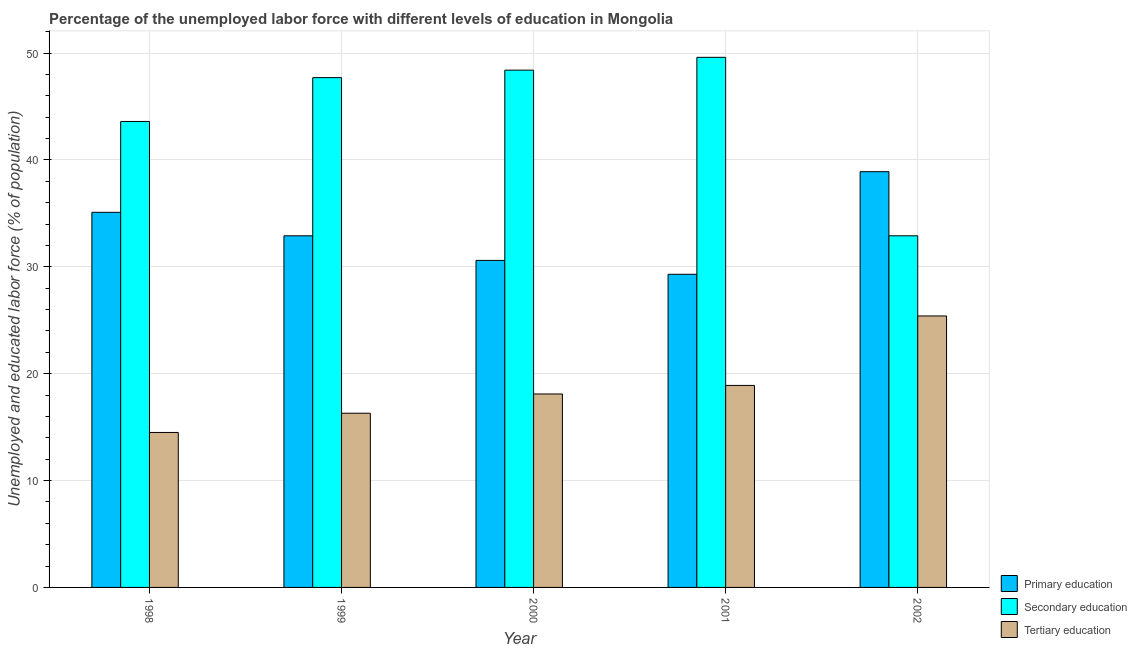Are the number of bars on each tick of the X-axis equal?
Ensure brevity in your answer.  Yes. How many bars are there on the 1st tick from the right?
Provide a short and direct response. 3. In how many cases, is the number of bars for a given year not equal to the number of legend labels?
Make the answer very short. 0. What is the percentage of labor force who received primary education in 1999?
Provide a short and direct response. 32.9. Across all years, what is the maximum percentage of labor force who received tertiary education?
Your response must be concise. 25.4. Across all years, what is the minimum percentage of labor force who received secondary education?
Offer a very short reply. 32.9. What is the total percentage of labor force who received secondary education in the graph?
Ensure brevity in your answer.  222.2. What is the difference between the percentage of labor force who received primary education in 1999 and that in 2002?
Keep it short and to the point. -6. What is the difference between the percentage of labor force who received secondary education in 1999 and the percentage of labor force who received primary education in 2001?
Give a very brief answer. -1.9. What is the average percentage of labor force who received tertiary education per year?
Make the answer very short. 18.64. In the year 1998, what is the difference between the percentage of labor force who received secondary education and percentage of labor force who received tertiary education?
Keep it short and to the point. 0. In how many years, is the percentage of labor force who received secondary education greater than 16 %?
Offer a very short reply. 5. What is the ratio of the percentage of labor force who received tertiary education in 1998 to that in 2002?
Your response must be concise. 0.57. What is the difference between the highest and the second highest percentage of labor force who received primary education?
Give a very brief answer. 3.8. What is the difference between the highest and the lowest percentage of labor force who received primary education?
Offer a terse response. 9.6. In how many years, is the percentage of labor force who received primary education greater than the average percentage of labor force who received primary education taken over all years?
Give a very brief answer. 2. What does the 2nd bar from the left in 2000 represents?
Provide a succinct answer. Secondary education. How many bars are there?
Make the answer very short. 15. Does the graph contain any zero values?
Keep it short and to the point. No. Does the graph contain grids?
Keep it short and to the point. Yes. How many legend labels are there?
Your answer should be very brief. 3. What is the title of the graph?
Give a very brief answer. Percentage of the unemployed labor force with different levels of education in Mongolia. Does "Ireland" appear as one of the legend labels in the graph?
Give a very brief answer. No. What is the label or title of the X-axis?
Your answer should be very brief. Year. What is the label or title of the Y-axis?
Offer a terse response. Unemployed and educated labor force (% of population). What is the Unemployed and educated labor force (% of population) of Primary education in 1998?
Give a very brief answer. 35.1. What is the Unemployed and educated labor force (% of population) in Secondary education in 1998?
Your response must be concise. 43.6. What is the Unemployed and educated labor force (% of population) in Tertiary education in 1998?
Provide a succinct answer. 14.5. What is the Unemployed and educated labor force (% of population) in Primary education in 1999?
Your answer should be very brief. 32.9. What is the Unemployed and educated labor force (% of population) in Secondary education in 1999?
Keep it short and to the point. 47.7. What is the Unemployed and educated labor force (% of population) of Tertiary education in 1999?
Give a very brief answer. 16.3. What is the Unemployed and educated labor force (% of population) of Primary education in 2000?
Make the answer very short. 30.6. What is the Unemployed and educated labor force (% of population) of Secondary education in 2000?
Provide a short and direct response. 48.4. What is the Unemployed and educated labor force (% of population) of Tertiary education in 2000?
Offer a terse response. 18.1. What is the Unemployed and educated labor force (% of population) of Primary education in 2001?
Offer a terse response. 29.3. What is the Unemployed and educated labor force (% of population) of Secondary education in 2001?
Your response must be concise. 49.6. What is the Unemployed and educated labor force (% of population) of Tertiary education in 2001?
Give a very brief answer. 18.9. What is the Unemployed and educated labor force (% of population) in Primary education in 2002?
Give a very brief answer. 38.9. What is the Unemployed and educated labor force (% of population) in Secondary education in 2002?
Your answer should be very brief. 32.9. What is the Unemployed and educated labor force (% of population) of Tertiary education in 2002?
Your response must be concise. 25.4. Across all years, what is the maximum Unemployed and educated labor force (% of population) in Primary education?
Make the answer very short. 38.9. Across all years, what is the maximum Unemployed and educated labor force (% of population) of Secondary education?
Make the answer very short. 49.6. Across all years, what is the maximum Unemployed and educated labor force (% of population) in Tertiary education?
Your answer should be very brief. 25.4. Across all years, what is the minimum Unemployed and educated labor force (% of population) of Primary education?
Offer a terse response. 29.3. Across all years, what is the minimum Unemployed and educated labor force (% of population) of Secondary education?
Make the answer very short. 32.9. Across all years, what is the minimum Unemployed and educated labor force (% of population) of Tertiary education?
Provide a short and direct response. 14.5. What is the total Unemployed and educated labor force (% of population) in Primary education in the graph?
Offer a terse response. 166.8. What is the total Unemployed and educated labor force (% of population) in Secondary education in the graph?
Make the answer very short. 222.2. What is the total Unemployed and educated labor force (% of population) in Tertiary education in the graph?
Provide a succinct answer. 93.2. What is the difference between the Unemployed and educated labor force (% of population) of Secondary education in 1998 and that in 1999?
Provide a succinct answer. -4.1. What is the difference between the Unemployed and educated labor force (% of population) in Tertiary education in 1998 and that in 2000?
Keep it short and to the point. -3.6. What is the difference between the Unemployed and educated labor force (% of population) in Primary education in 1998 and that in 2001?
Offer a terse response. 5.8. What is the difference between the Unemployed and educated labor force (% of population) of Secondary education in 1998 and that in 2001?
Your response must be concise. -6. What is the difference between the Unemployed and educated labor force (% of population) of Tertiary education in 1998 and that in 2001?
Keep it short and to the point. -4.4. What is the difference between the Unemployed and educated labor force (% of population) in Primary education in 1998 and that in 2002?
Keep it short and to the point. -3.8. What is the difference between the Unemployed and educated labor force (% of population) of Secondary education in 1998 and that in 2002?
Provide a short and direct response. 10.7. What is the difference between the Unemployed and educated labor force (% of population) in Tertiary education in 1998 and that in 2002?
Your answer should be compact. -10.9. What is the difference between the Unemployed and educated labor force (% of population) of Secondary education in 1999 and that in 2000?
Offer a terse response. -0.7. What is the difference between the Unemployed and educated labor force (% of population) in Tertiary education in 1999 and that in 2000?
Provide a succinct answer. -1.8. What is the difference between the Unemployed and educated labor force (% of population) of Secondary education in 1999 and that in 2001?
Provide a short and direct response. -1.9. What is the difference between the Unemployed and educated labor force (% of population) in Tertiary education in 1999 and that in 2001?
Give a very brief answer. -2.6. What is the difference between the Unemployed and educated labor force (% of population) of Secondary education in 1999 and that in 2002?
Offer a very short reply. 14.8. What is the difference between the Unemployed and educated labor force (% of population) of Primary education in 2000 and that in 2002?
Provide a short and direct response. -8.3. What is the difference between the Unemployed and educated labor force (% of population) of Primary education in 2001 and that in 2002?
Provide a short and direct response. -9.6. What is the difference between the Unemployed and educated labor force (% of population) of Secondary education in 2001 and that in 2002?
Provide a succinct answer. 16.7. What is the difference between the Unemployed and educated labor force (% of population) in Tertiary education in 2001 and that in 2002?
Give a very brief answer. -6.5. What is the difference between the Unemployed and educated labor force (% of population) in Primary education in 1998 and the Unemployed and educated labor force (% of population) in Secondary education in 1999?
Ensure brevity in your answer.  -12.6. What is the difference between the Unemployed and educated labor force (% of population) of Secondary education in 1998 and the Unemployed and educated labor force (% of population) of Tertiary education in 1999?
Provide a succinct answer. 27.3. What is the difference between the Unemployed and educated labor force (% of population) in Primary education in 1998 and the Unemployed and educated labor force (% of population) in Secondary education in 2000?
Your response must be concise. -13.3. What is the difference between the Unemployed and educated labor force (% of population) in Primary education in 1998 and the Unemployed and educated labor force (% of population) in Tertiary education in 2001?
Offer a terse response. 16.2. What is the difference between the Unemployed and educated labor force (% of population) in Secondary education in 1998 and the Unemployed and educated labor force (% of population) in Tertiary education in 2001?
Offer a terse response. 24.7. What is the difference between the Unemployed and educated labor force (% of population) in Primary education in 1998 and the Unemployed and educated labor force (% of population) in Secondary education in 2002?
Make the answer very short. 2.2. What is the difference between the Unemployed and educated labor force (% of population) of Primary education in 1998 and the Unemployed and educated labor force (% of population) of Tertiary education in 2002?
Provide a succinct answer. 9.7. What is the difference between the Unemployed and educated labor force (% of population) of Secondary education in 1998 and the Unemployed and educated labor force (% of population) of Tertiary education in 2002?
Your response must be concise. 18.2. What is the difference between the Unemployed and educated labor force (% of population) of Primary education in 1999 and the Unemployed and educated labor force (% of population) of Secondary education in 2000?
Give a very brief answer. -15.5. What is the difference between the Unemployed and educated labor force (% of population) of Secondary education in 1999 and the Unemployed and educated labor force (% of population) of Tertiary education in 2000?
Your answer should be compact. 29.6. What is the difference between the Unemployed and educated labor force (% of population) of Primary education in 1999 and the Unemployed and educated labor force (% of population) of Secondary education in 2001?
Provide a short and direct response. -16.7. What is the difference between the Unemployed and educated labor force (% of population) of Primary education in 1999 and the Unemployed and educated labor force (% of population) of Tertiary education in 2001?
Your response must be concise. 14. What is the difference between the Unemployed and educated labor force (% of population) of Secondary education in 1999 and the Unemployed and educated labor force (% of population) of Tertiary education in 2001?
Offer a very short reply. 28.8. What is the difference between the Unemployed and educated labor force (% of population) of Secondary education in 1999 and the Unemployed and educated labor force (% of population) of Tertiary education in 2002?
Ensure brevity in your answer.  22.3. What is the difference between the Unemployed and educated labor force (% of population) of Primary education in 2000 and the Unemployed and educated labor force (% of population) of Secondary education in 2001?
Make the answer very short. -19. What is the difference between the Unemployed and educated labor force (% of population) in Primary education in 2000 and the Unemployed and educated labor force (% of population) in Tertiary education in 2001?
Provide a short and direct response. 11.7. What is the difference between the Unemployed and educated labor force (% of population) in Secondary education in 2000 and the Unemployed and educated labor force (% of population) in Tertiary education in 2001?
Ensure brevity in your answer.  29.5. What is the difference between the Unemployed and educated labor force (% of population) of Primary education in 2000 and the Unemployed and educated labor force (% of population) of Tertiary education in 2002?
Provide a short and direct response. 5.2. What is the difference between the Unemployed and educated labor force (% of population) in Primary education in 2001 and the Unemployed and educated labor force (% of population) in Tertiary education in 2002?
Offer a very short reply. 3.9. What is the difference between the Unemployed and educated labor force (% of population) in Secondary education in 2001 and the Unemployed and educated labor force (% of population) in Tertiary education in 2002?
Give a very brief answer. 24.2. What is the average Unemployed and educated labor force (% of population) in Primary education per year?
Give a very brief answer. 33.36. What is the average Unemployed and educated labor force (% of population) of Secondary education per year?
Keep it short and to the point. 44.44. What is the average Unemployed and educated labor force (% of population) of Tertiary education per year?
Give a very brief answer. 18.64. In the year 1998, what is the difference between the Unemployed and educated labor force (% of population) of Primary education and Unemployed and educated labor force (% of population) of Secondary education?
Ensure brevity in your answer.  -8.5. In the year 1998, what is the difference between the Unemployed and educated labor force (% of population) of Primary education and Unemployed and educated labor force (% of population) of Tertiary education?
Offer a terse response. 20.6. In the year 1998, what is the difference between the Unemployed and educated labor force (% of population) in Secondary education and Unemployed and educated labor force (% of population) in Tertiary education?
Provide a short and direct response. 29.1. In the year 1999, what is the difference between the Unemployed and educated labor force (% of population) of Primary education and Unemployed and educated labor force (% of population) of Secondary education?
Offer a very short reply. -14.8. In the year 1999, what is the difference between the Unemployed and educated labor force (% of population) of Secondary education and Unemployed and educated labor force (% of population) of Tertiary education?
Offer a terse response. 31.4. In the year 2000, what is the difference between the Unemployed and educated labor force (% of population) of Primary education and Unemployed and educated labor force (% of population) of Secondary education?
Keep it short and to the point. -17.8. In the year 2000, what is the difference between the Unemployed and educated labor force (% of population) in Primary education and Unemployed and educated labor force (% of population) in Tertiary education?
Provide a short and direct response. 12.5. In the year 2000, what is the difference between the Unemployed and educated labor force (% of population) of Secondary education and Unemployed and educated labor force (% of population) of Tertiary education?
Offer a terse response. 30.3. In the year 2001, what is the difference between the Unemployed and educated labor force (% of population) of Primary education and Unemployed and educated labor force (% of population) of Secondary education?
Your answer should be very brief. -20.3. In the year 2001, what is the difference between the Unemployed and educated labor force (% of population) in Primary education and Unemployed and educated labor force (% of population) in Tertiary education?
Give a very brief answer. 10.4. In the year 2001, what is the difference between the Unemployed and educated labor force (% of population) of Secondary education and Unemployed and educated labor force (% of population) of Tertiary education?
Make the answer very short. 30.7. In the year 2002, what is the difference between the Unemployed and educated labor force (% of population) of Primary education and Unemployed and educated labor force (% of population) of Tertiary education?
Provide a succinct answer. 13.5. In the year 2002, what is the difference between the Unemployed and educated labor force (% of population) of Secondary education and Unemployed and educated labor force (% of population) of Tertiary education?
Offer a very short reply. 7.5. What is the ratio of the Unemployed and educated labor force (% of population) in Primary education in 1998 to that in 1999?
Give a very brief answer. 1.07. What is the ratio of the Unemployed and educated labor force (% of population) of Secondary education in 1998 to that in 1999?
Your answer should be compact. 0.91. What is the ratio of the Unemployed and educated labor force (% of population) in Tertiary education in 1998 to that in 1999?
Give a very brief answer. 0.89. What is the ratio of the Unemployed and educated labor force (% of population) in Primary education in 1998 to that in 2000?
Ensure brevity in your answer.  1.15. What is the ratio of the Unemployed and educated labor force (% of population) in Secondary education in 1998 to that in 2000?
Give a very brief answer. 0.9. What is the ratio of the Unemployed and educated labor force (% of population) in Tertiary education in 1998 to that in 2000?
Offer a terse response. 0.8. What is the ratio of the Unemployed and educated labor force (% of population) in Primary education in 1998 to that in 2001?
Give a very brief answer. 1.2. What is the ratio of the Unemployed and educated labor force (% of population) in Secondary education in 1998 to that in 2001?
Keep it short and to the point. 0.88. What is the ratio of the Unemployed and educated labor force (% of population) of Tertiary education in 1998 to that in 2001?
Make the answer very short. 0.77. What is the ratio of the Unemployed and educated labor force (% of population) in Primary education in 1998 to that in 2002?
Your answer should be compact. 0.9. What is the ratio of the Unemployed and educated labor force (% of population) in Secondary education in 1998 to that in 2002?
Your response must be concise. 1.33. What is the ratio of the Unemployed and educated labor force (% of population) in Tertiary education in 1998 to that in 2002?
Offer a very short reply. 0.57. What is the ratio of the Unemployed and educated labor force (% of population) in Primary education in 1999 to that in 2000?
Your answer should be compact. 1.08. What is the ratio of the Unemployed and educated labor force (% of population) in Secondary education in 1999 to that in 2000?
Give a very brief answer. 0.99. What is the ratio of the Unemployed and educated labor force (% of population) of Tertiary education in 1999 to that in 2000?
Your answer should be compact. 0.9. What is the ratio of the Unemployed and educated labor force (% of population) of Primary education in 1999 to that in 2001?
Your answer should be compact. 1.12. What is the ratio of the Unemployed and educated labor force (% of population) in Secondary education in 1999 to that in 2001?
Your answer should be very brief. 0.96. What is the ratio of the Unemployed and educated labor force (% of population) in Tertiary education in 1999 to that in 2001?
Offer a very short reply. 0.86. What is the ratio of the Unemployed and educated labor force (% of population) of Primary education in 1999 to that in 2002?
Make the answer very short. 0.85. What is the ratio of the Unemployed and educated labor force (% of population) of Secondary education in 1999 to that in 2002?
Keep it short and to the point. 1.45. What is the ratio of the Unemployed and educated labor force (% of population) in Tertiary education in 1999 to that in 2002?
Give a very brief answer. 0.64. What is the ratio of the Unemployed and educated labor force (% of population) in Primary education in 2000 to that in 2001?
Keep it short and to the point. 1.04. What is the ratio of the Unemployed and educated labor force (% of population) of Secondary education in 2000 to that in 2001?
Offer a terse response. 0.98. What is the ratio of the Unemployed and educated labor force (% of population) in Tertiary education in 2000 to that in 2001?
Your answer should be compact. 0.96. What is the ratio of the Unemployed and educated labor force (% of population) in Primary education in 2000 to that in 2002?
Ensure brevity in your answer.  0.79. What is the ratio of the Unemployed and educated labor force (% of population) in Secondary education in 2000 to that in 2002?
Offer a terse response. 1.47. What is the ratio of the Unemployed and educated labor force (% of population) of Tertiary education in 2000 to that in 2002?
Your answer should be very brief. 0.71. What is the ratio of the Unemployed and educated labor force (% of population) in Primary education in 2001 to that in 2002?
Your response must be concise. 0.75. What is the ratio of the Unemployed and educated labor force (% of population) of Secondary education in 2001 to that in 2002?
Offer a terse response. 1.51. What is the ratio of the Unemployed and educated labor force (% of population) in Tertiary education in 2001 to that in 2002?
Make the answer very short. 0.74. What is the difference between the highest and the second highest Unemployed and educated labor force (% of population) in Primary education?
Your answer should be very brief. 3.8. What is the difference between the highest and the second highest Unemployed and educated labor force (% of population) of Secondary education?
Offer a terse response. 1.2. What is the difference between the highest and the lowest Unemployed and educated labor force (% of population) in Primary education?
Keep it short and to the point. 9.6. What is the difference between the highest and the lowest Unemployed and educated labor force (% of population) of Secondary education?
Ensure brevity in your answer.  16.7. 